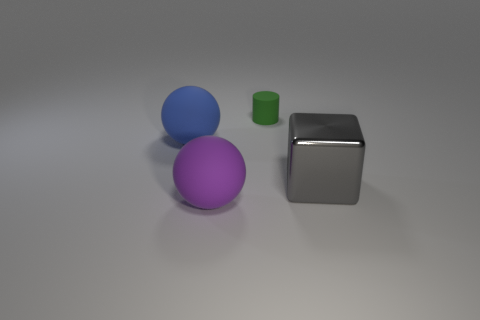Add 1 big purple matte things. How many objects exist? 5 Subtract all blocks. How many objects are left? 3 Add 4 rubber balls. How many rubber balls exist? 6 Subtract 0 gray cylinders. How many objects are left? 4 Subtract all large purple spheres. Subtract all big gray cylinders. How many objects are left? 3 Add 1 tiny matte objects. How many tiny matte objects are left? 2 